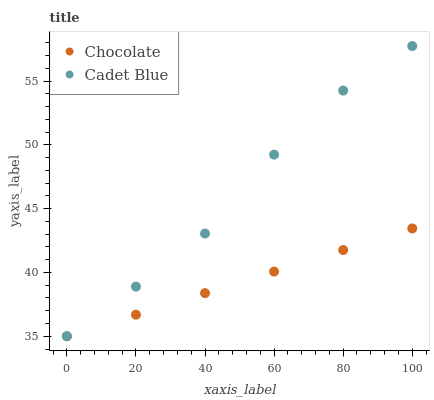Does Chocolate have the minimum area under the curve?
Answer yes or no. Yes. Does Cadet Blue have the maximum area under the curve?
Answer yes or no. Yes. Does Chocolate have the maximum area under the curve?
Answer yes or no. No. Is Chocolate the smoothest?
Answer yes or no. Yes. Is Cadet Blue the roughest?
Answer yes or no. Yes. Is Chocolate the roughest?
Answer yes or no. No. Does Cadet Blue have the lowest value?
Answer yes or no. Yes. Does Cadet Blue have the highest value?
Answer yes or no. Yes. Does Chocolate have the highest value?
Answer yes or no. No. Does Cadet Blue intersect Chocolate?
Answer yes or no. Yes. Is Cadet Blue less than Chocolate?
Answer yes or no. No. Is Cadet Blue greater than Chocolate?
Answer yes or no. No. 